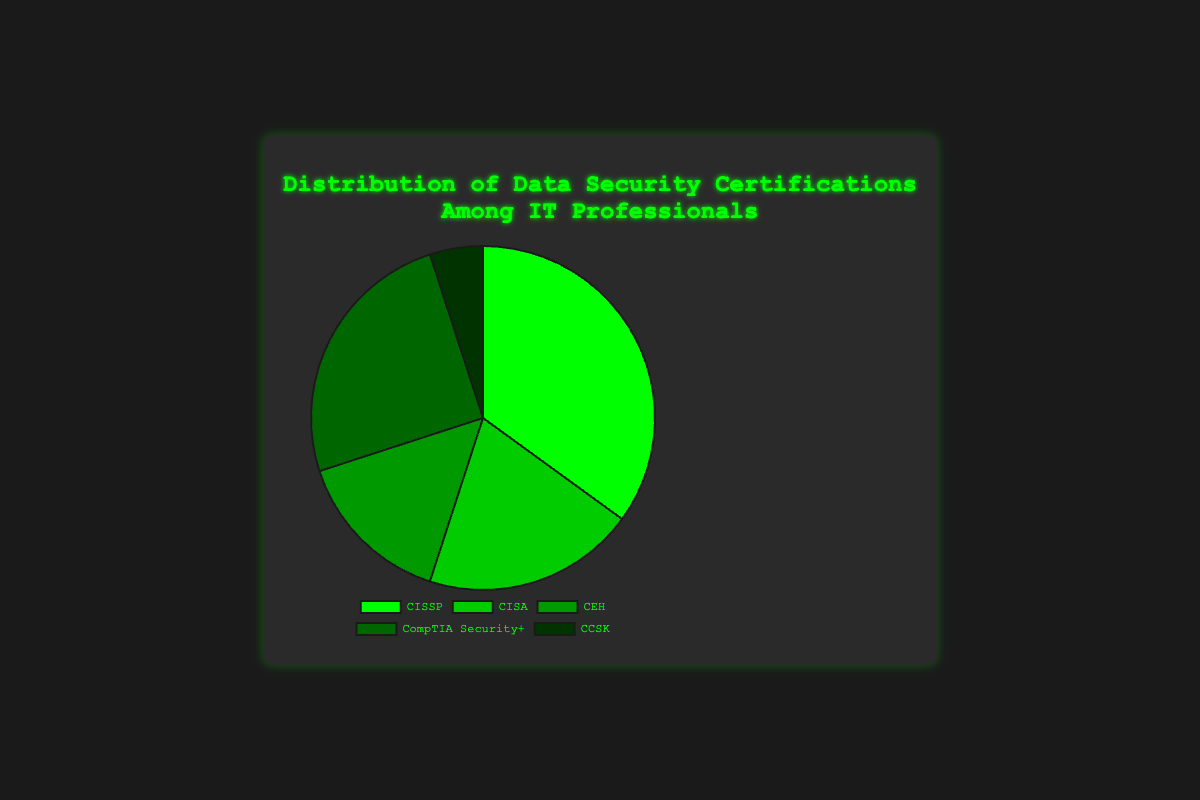What certification has the largest percentage of IT professionals? CISSP is at the top with a 35% distribution among IT professionals, as the label corresponding to CISSP shows the largest percentage.
Answer: CISSP Which certification holds the smallest market share among IT professionals? CCSK has the smallest slice in the pie chart, representing only 5% of IT professionals.
Answer: CCSK How many certifications collectively represent more than 50% of IT professionals? The CISSP and CompTIA Security+ slices together sum up to 35% + 25% = 60%, which is more than 50% of the total.
Answer: 2 Which certification has a distribution closest to the average? The average percentage can be calculated as (35 + 20 + 15 + 25 + 5) / 5 = 20%. The certification closest to this is CISA, which has a percentage of 20%.
Answer: CISA Compare the distribution of CISSP and CEH certifications. Which is greater, and by how much? Comparing the percentages, CISSP has 35% and CEH has 15%. The difference is 35% - 15% = 20%.
Answer: CISSP by 20% If you sum the percentages of CISA and CompTIA Security+, what will you get? The sum of the percentages of CISA and CompTIA Security+ is 20% + 25% = 45%.
Answer: 45% What is the difference between the percentage of CISSP and CCSK? The percentage difference between CISSP and CCSK is 35% - 5% = 30%.
Answer: 30% How does the percentage of CompTIA Security+ compare to the combined percentage of CEH and CCSK? The combined percentage of CEH and CCSK is 15% + 5% = 20%. CompTIA Security+ alone accounts for 25%, which is 5% more.
Answer: CompTIA Security+ is 5% more Considering CISSP and CompTIA Security+, if a new certification takes over the combined total percentage, what percentage would that new certification have? The combined percentage of CISSP and CompTIA Security+ is 35% + 25% = 60%.
Answer: 60% Which pair of certifications, when combined, equals the percentage of CISSP? CEH and CompTIA Security+ together total 15% + 25% = 40%. The closest pair is CISA (20%) and CompTIA Security+ (25%), which adds up to 45%, but no exact combination sums up to 35%. However, within context limits, CISA and CompTIA Security+ together are close enough.
Answer: CISA and CompTIA Security+ 